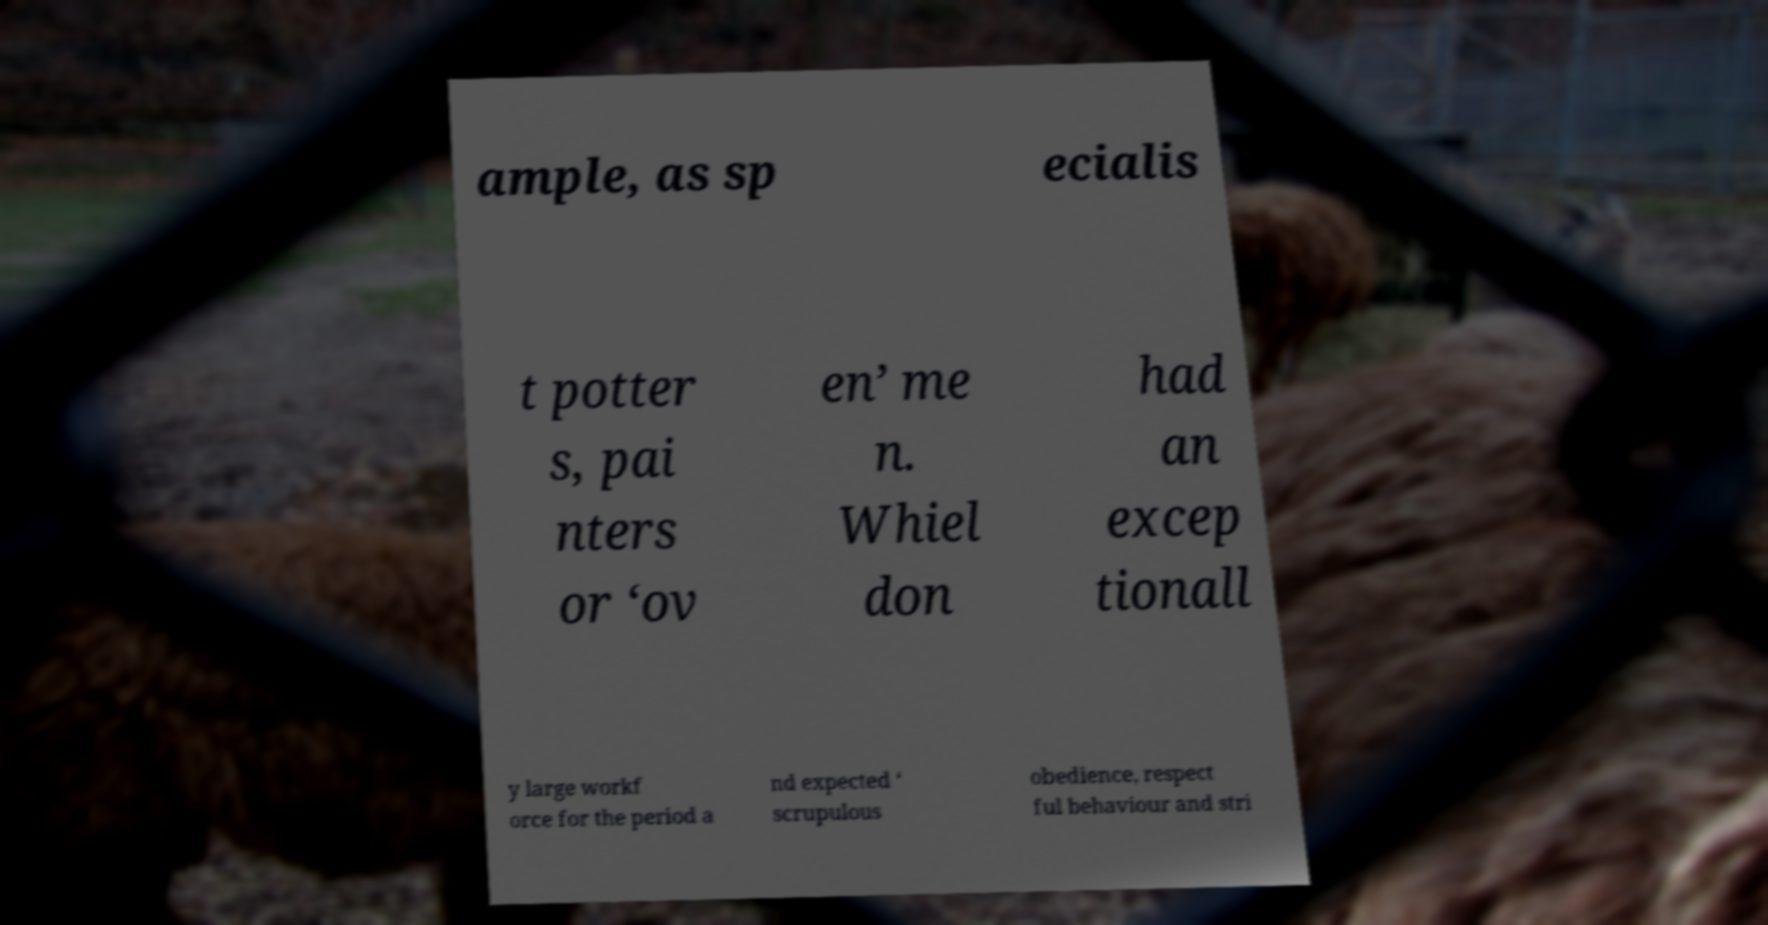Please identify and transcribe the text found in this image. ample, as sp ecialis t potter s, pai nters or ‘ov en’ me n. Whiel don had an excep tionall y large workf orce for the period a nd expected ‘ scrupulous obedience, respect ful behaviour and stri 